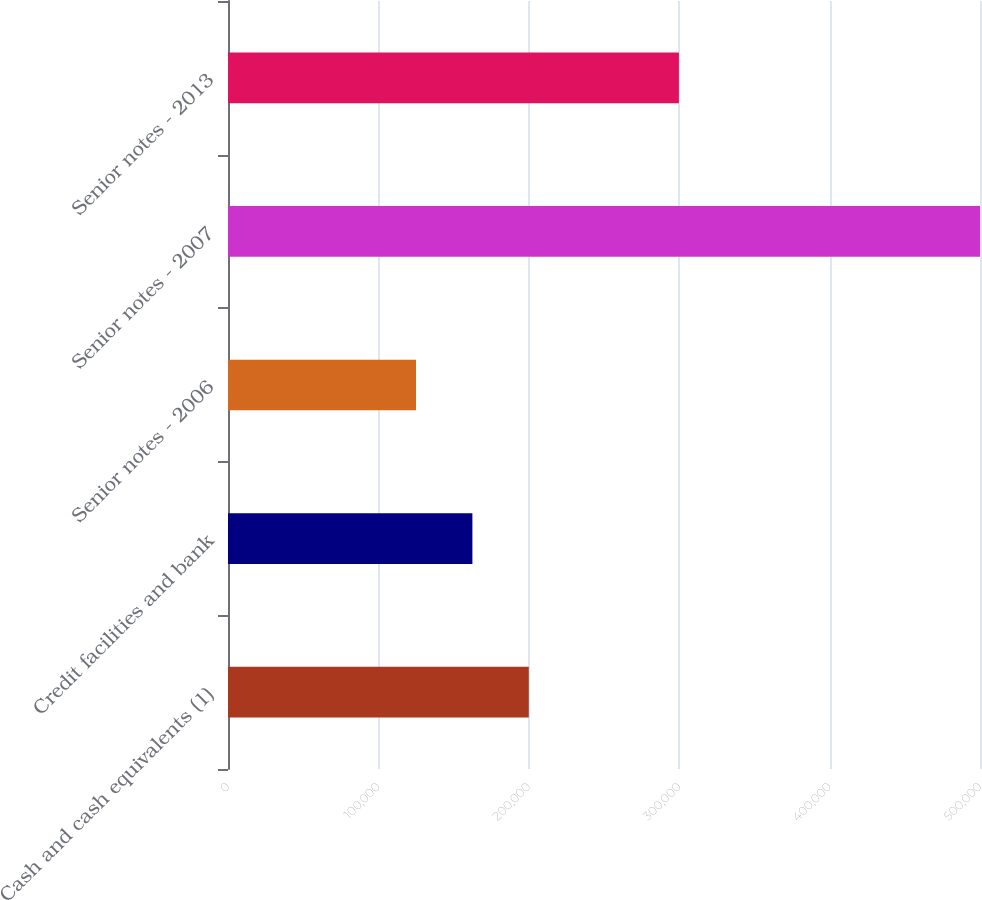Convert chart. <chart><loc_0><loc_0><loc_500><loc_500><bar_chart><fcel>Cash and cash equivalents (1)<fcel>Credit facilities and bank<fcel>Senior notes - 2006<fcel>Senior notes - 2007<fcel>Senior notes - 2013<nl><fcel>200000<fcel>162500<fcel>125000<fcel>500000<fcel>299809<nl></chart> 